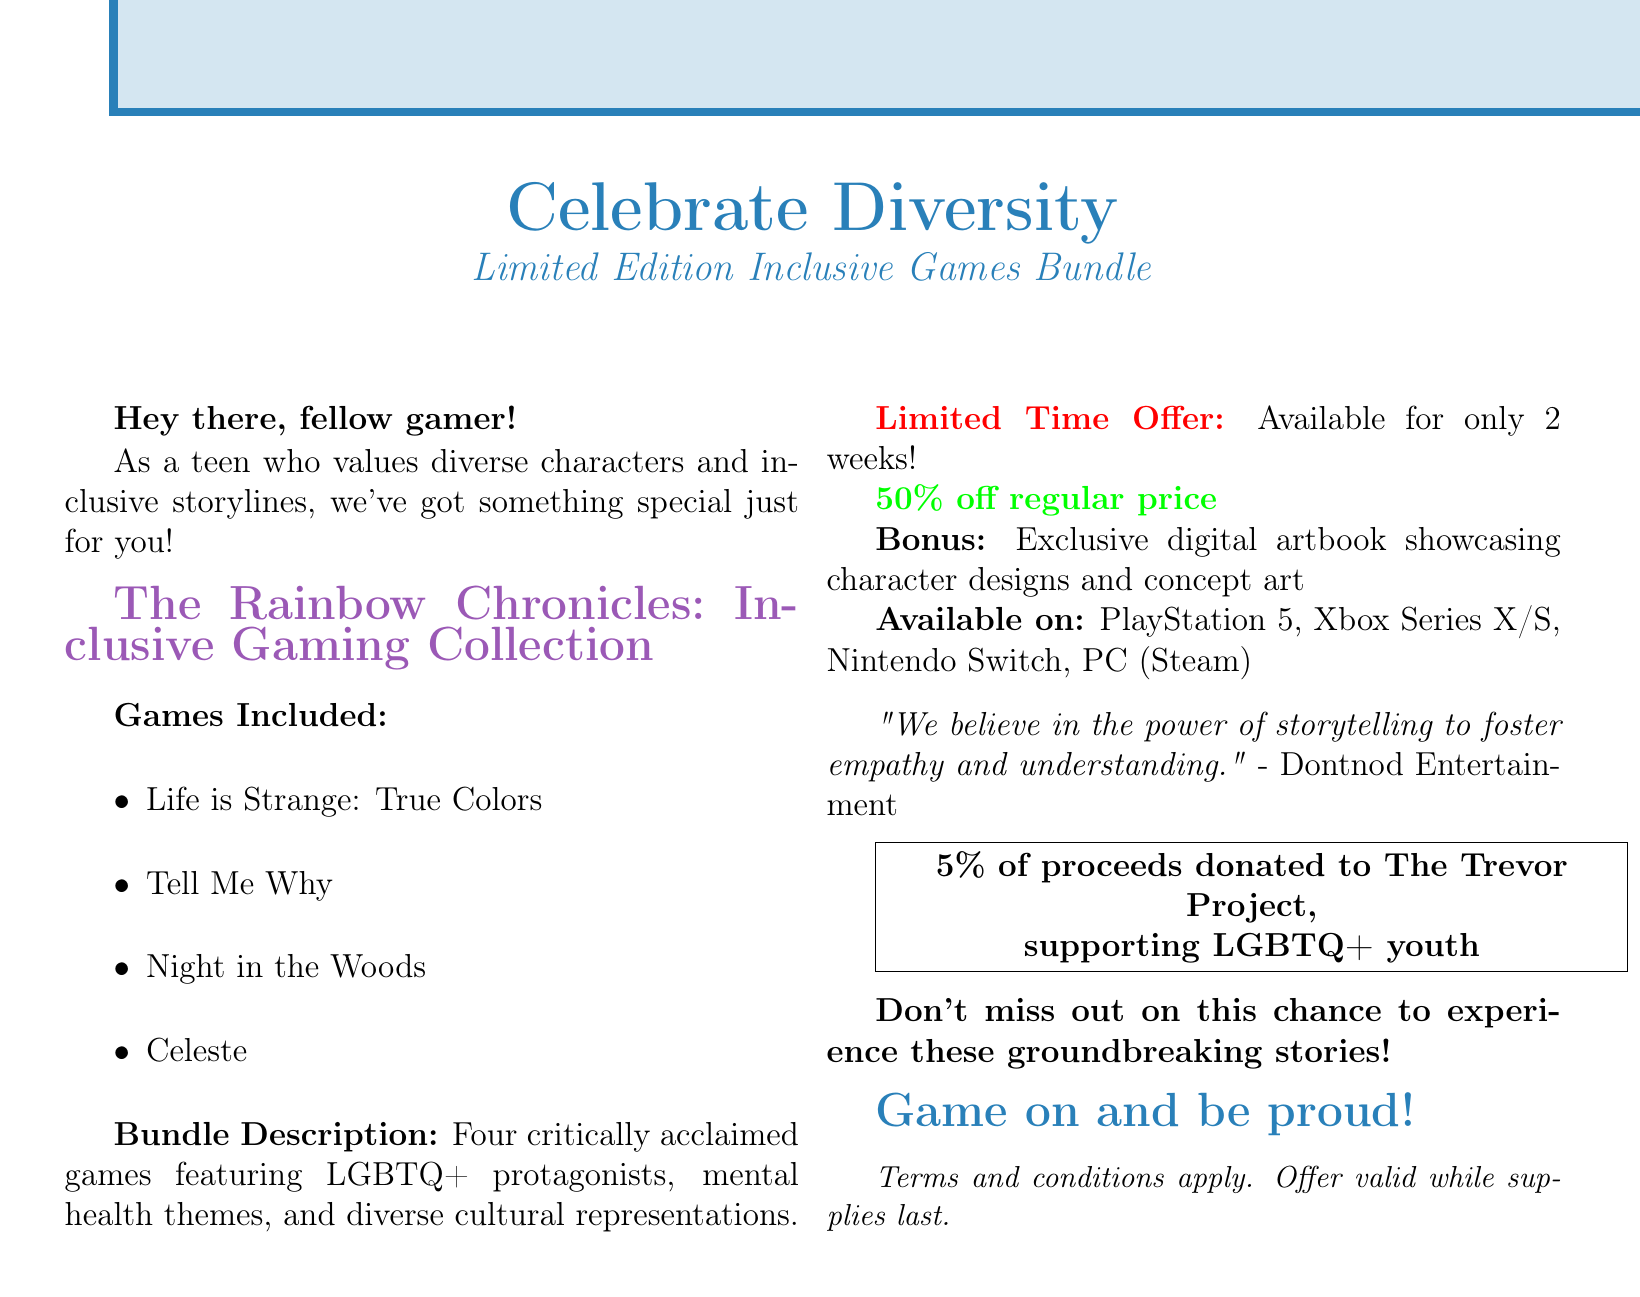What is the name of the bundle? The bundle is specifically named in the document.
Answer: The Rainbow Chronicles: Inclusive Gaming Collection How long is the offer available? The document states the duration of the promotional offer.
Answer: 2 weeks What percentage discount is being offered? The discount percentage is mentioned in the document.
Answer: 50% off regular price Which platforms is the bundle available on? The platforms where the games can be played are listed in the document.
Answer: PlayStation 5, Xbox Series X/S, Nintendo Switch, PC (Steam) What is included as bonus content? The document mentions what bonus content comes with the bundle.
Answer: Exclusive digital artbook showcasing character designs and concept art What cause does a portion of the proceeds support? The document explains the community impact of a portion of the sales.
Answer: The Trevor Project Who is quoted in the document regarding storytelling? The document includes a quote from a specific developer.
Answer: Dontnod Entertainment What themes do the included games explore? The document provides a brief description of the themes in the games.
Answer: LGBTQ+ protagonists, mental health themes, and diverse cultural representations 